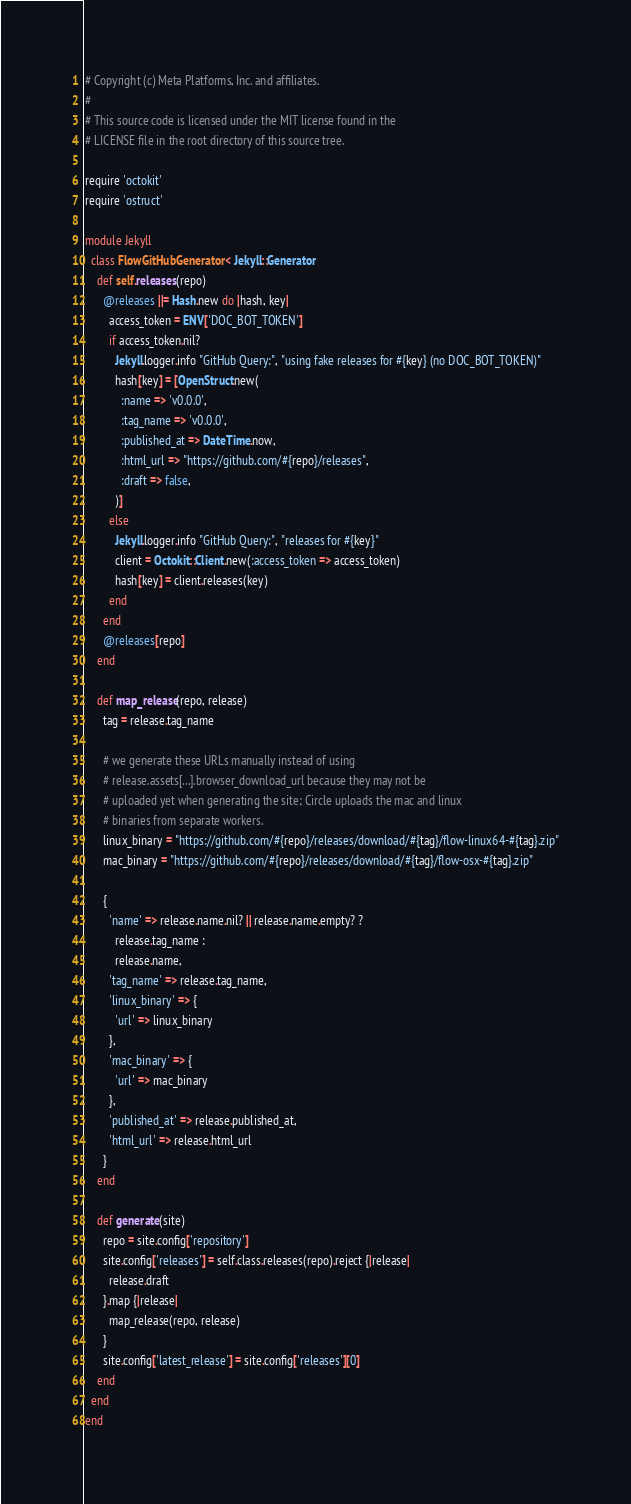<code> <loc_0><loc_0><loc_500><loc_500><_Ruby_># Copyright (c) Meta Platforms, Inc. and affiliates.
#
# This source code is licensed under the MIT license found in the
# LICENSE file in the root directory of this source tree.

require 'octokit'
require 'ostruct'

module Jekyll
  class FlowGitHubGenerator < Jekyll::Generator
    def self.releases(repo)
      @releases ||= Hash.new do |hash, key|
        access_token = ENV['DOC_BOT_TOKEN']
        if access_token.nil?
          Jekyll.logger.info "GitHub Query:", "using fake releases for #{key} (no DOC_BOT_TOKEN)"
          hash[key] = [OpenStruct.new(
            :name => 'v0.0.0',
            :tag_name => 'v0.0.0',
            :published_at => DateTime.now,
            :html_url => "https://github.com/#{repo}/releases",
            :draft => false,
          )]
        else
          Jekyll.logger.info "GitHub Query:", "releases for #{key}"
          client = Octokit::Client.new(:access_token => access_token)
          hash[key] = client.releases(key)
        end
      end
      @releases[repo]
    end

    def map_release(repo, release)
      tag = release.tag_name

      # we generate these URLs manually instead of using
      # release.assets[...].browser_download_url because they may not be
      # uploaded yet when generating the site; Circle uploads the mac and linux
      # binaries from separate workers.
      linux_binary = "https://github.com/#{repo}/releases/download/#{tag}/flow-linux64-#{tag}.zip"
      mac_binary = "https://github.com/#{repo}/releases/download/#{tag}/flow-osx-#{tag}.zip"

      {
        'name' => release.name.nil? || release.name.empty? ?
          release.tag_name :
          release.name,
        'tag_name' => release.tag_name,
        'linux_binary' => {
          'url' => linux_binary
        },
        'mac_binary' => {
          'url' => mac_binary
        },
        'published_at' => release.published_at,
        'html_url' => release.html_url
      }
    end

    def generate(site)
      repo = site.config['repository']
      site.config['releases'] = self.class.releases(repo).reject {|release|
        release.draft
      }.map {|release|
        map_release(repo, release)
      }
      site.config['latest_release'] = site.config['releases'][0]
    end
  end
end
</code> 